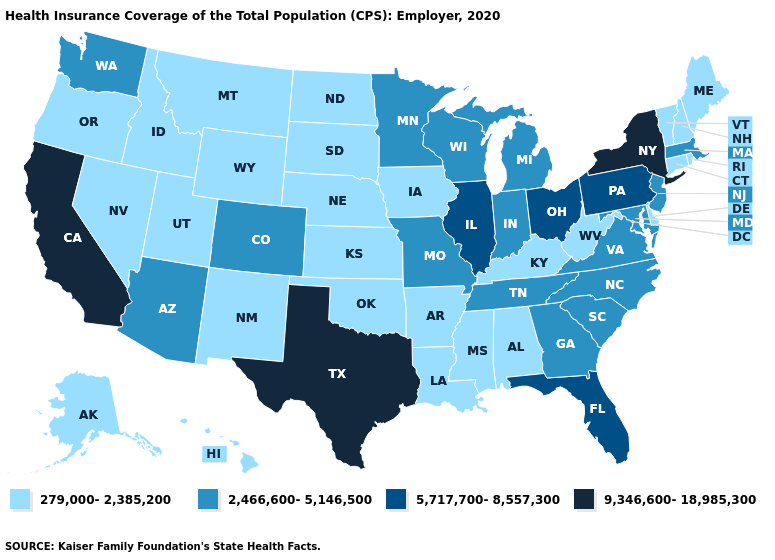Does New Mexico have a lower value than Minnesota?
Keep it brief. Yes. Does Alaska have the lowest value in the West?
Keep it brief. Yes. What is the value of Wyoming?
Keep it brief. 279,000-2,385,200. Name the states that have a value in the range 2,466,600-5,146,500?
Be succinct. Arizona, Colorado, Georgia, Indiana, Maryland, Massachusetts, Michigan, Minnesota, Missouri, New Jersey, North Carolina, South Carolina, Tennessee, Virginia, Washington, Wisconsin. Which states hav the highest value in the South?
Answer briefly. Texas. Does California have the highest value in the USA?
Answer briefly. Yes. Which states have the lowest value in the USA?
Short answer required. Alabama, Alaska, Arkansas, Connecticut, Delaware, Hawaii, Idaho, Iowa, Kansas, Kentucky, Louisiana, Maine, Mississippi, Montana, Nebraska, Nevada, New Hampshire, New Mexico, North Dakota, Oklahoma, Oregon, Rhode Island, South Dakota, Utah, Vermont, West Virginia, Wyoming. Name the states that have a value in the range 5,717,700-8,557,300?
Concise answer only. Florida, Illinois, Ohio, Pennsylvania. Among the states that border Delaware , does Pennsylvania have the highest value?
Quick response, please. Yes. What is the value of Massachusetts?
Give a very brief answer. 2,466,600-5,146,500. Does Oklahoma have a lower value than Indiana?
Give a very brief answer. Yes. What is the value of Pennsylvania?
Short answer required. 5,717,700-8,557,300. What is the highest value in states that border Maine?
Keep it brief. 279,000-2,385,200. Does Alaska have the same value as Delaware?
Give a very brief answer. Yes. 